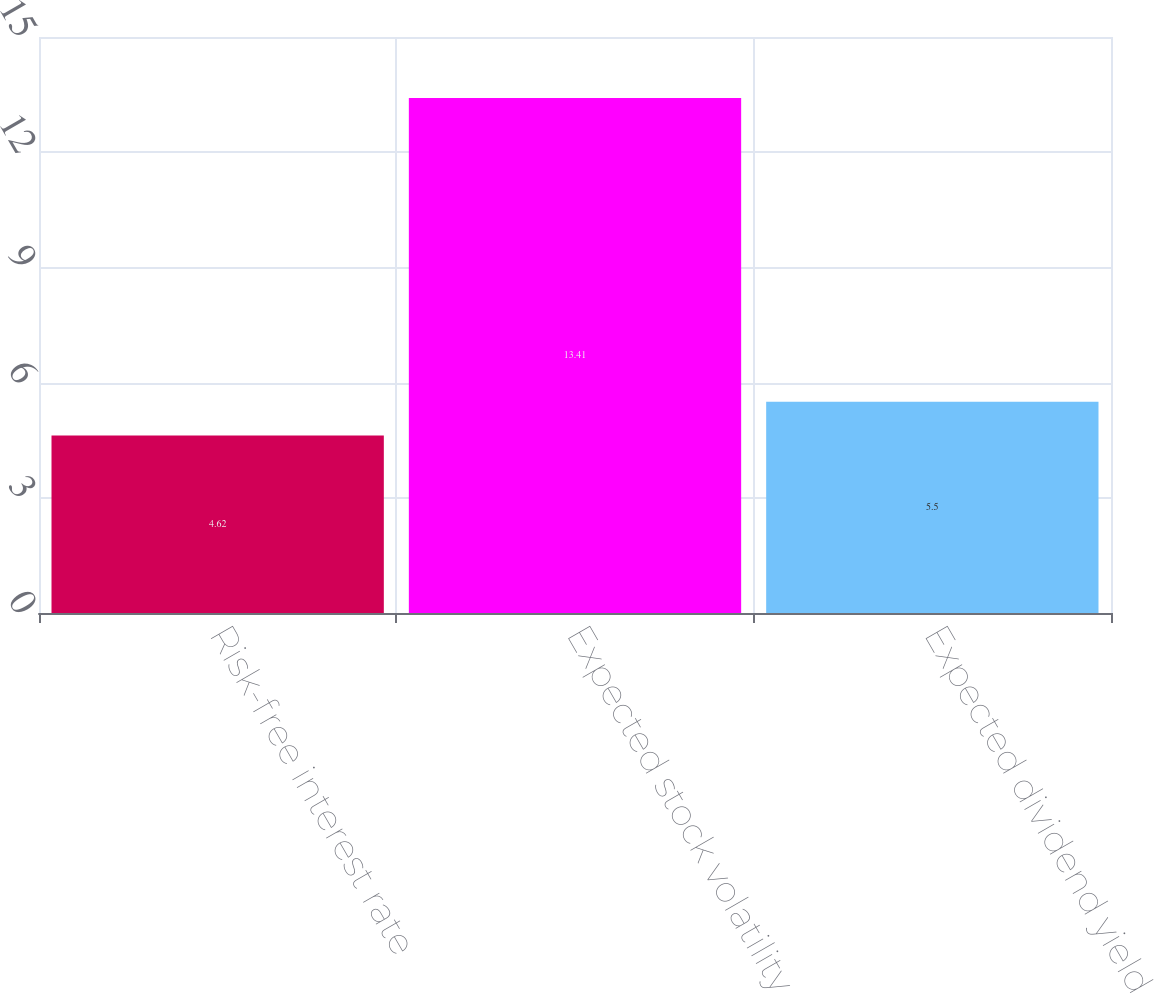Convert chart to OTSL. <chart><loc_0><loc_0><loc_500><loc_500><bar_chart><fcel>Risk-free interest rate<fcel>Expected stock volatility<fcel>Expected dividend yield<nl><fcel>4.62<fcel>13.41<fcel>5.5<nl></chart> 